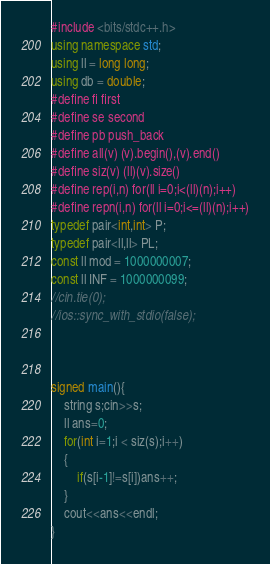Convert code to text. <code><loc_0><loc_0><loc_500><loc_500><_C++_>#include <bits/stdc++.h>
using namespace std;
using ll = long long;
using db = double;
#define fi first
#define se second
#define pb push_back
#define all(v) (v).begin(),(v).end()
#define siz(v) (ll)(v).size()
#define rep(i,n) for(ll i=0;i<(ll)(n);i++)
#define repn(i,n) for(ll i=0;i<=(ll)(n);i++)
typedef pair<int,int> P;
typedef pair<ll,ll> PL;
const ll mod = 1000000007;
const ll INF = 1000000099;
//cin.tie(0);
//ios::sync_with_stdio(false);



signed main(){
    string s;cin>>s;
    ll ans=0;
    for(int i=1;i < siz(s);i++)
    {
        if(s[i-1]!=s[i])ans++;
    }
    cout<<ans<<endl;
}
</code> 